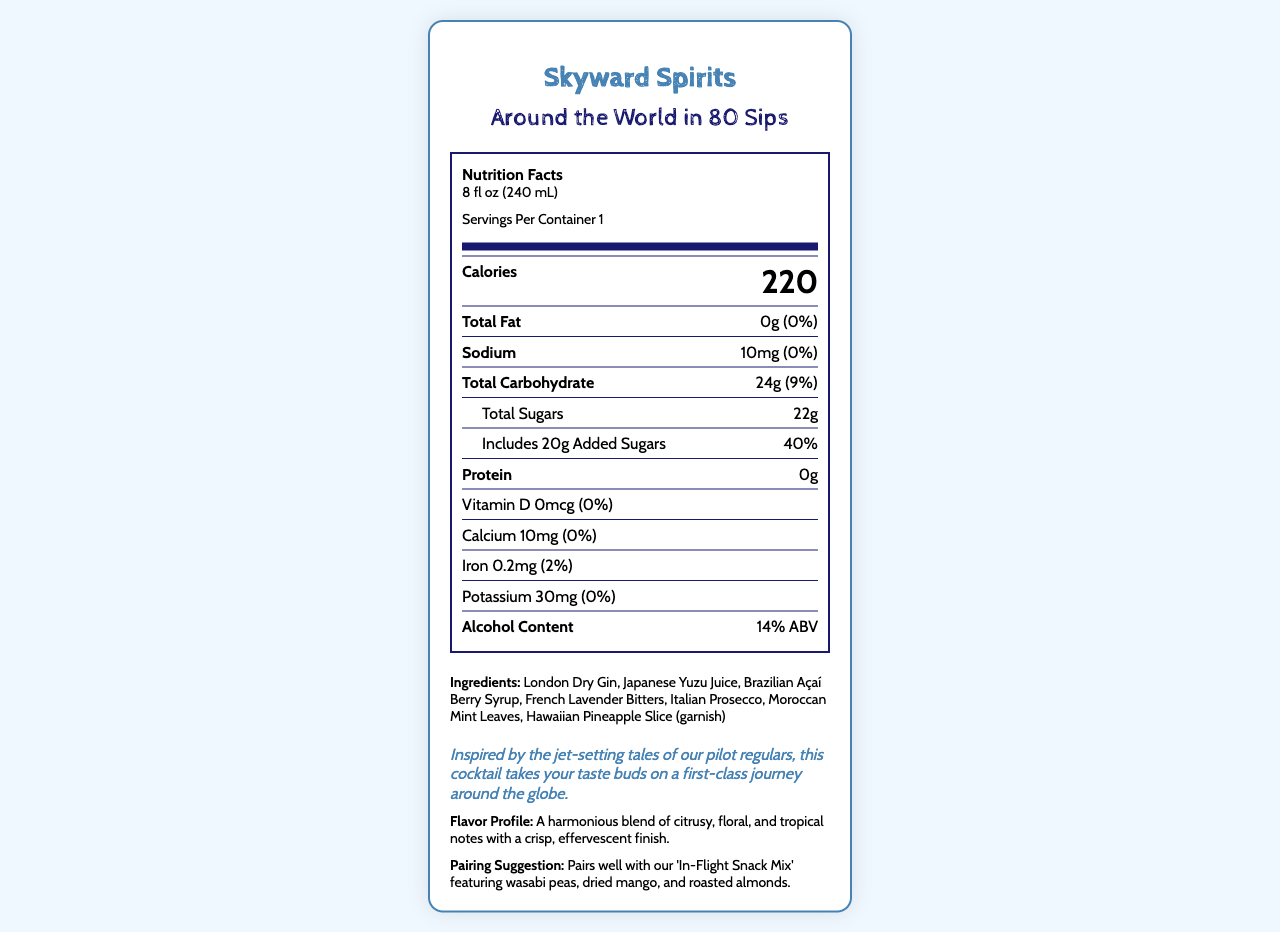what is the product name? The product name is clearly stated at the beginning of the document.
Answer: Around the World in 80 Sips what is the serving size of the cocktail? The serving size is specified in the document as "8 fl oz (240 mL)".
Answer: 8 fl oz (240 mL) how many calories are in one serving? The document lists the calorie content for one serving as 220 calories.
Answer: 220 what is the amount of total fat in this cocktail? The document states that the total fat content is 0g.
Answer: 0g how much added sugar is included in the cocktail? According to the document, the cocktail includes 20g of added sugars.
Answer: 20g what is the alcohol content of the cocktail? The document specifies that the alcohol content is 14% ABV.
Answer: 14% ABV Which of the following ingredients is used as a garnish? A. French Lavender Bitters B. Hawaiian Pineapple Slice C. Italian Prosecco D. Moroccan Mint Leaves The document lists "Hawaiian Pineapple Slice (garnish)" among the ingredients.
Answer: B. Hawaiian Pineapple Slice How many grams of protein does the cocktail contain? The document states that the protein content is 0g.
Answer: 0g what is the daily value percentage for calcium in the cocktail? The document shows that the daily value percentage for calcium is 0%.
Answer: 0% Which of the following best describes the flavor profile of the cocktail? I. Sour II. Bitter III. Citrusy IV. Spicy The document mentions "A harmonious blend of citrusy, floral, and tropical notes with a crisp, effervescent finish." under the flavor profile section.
Answer: III. Citrusy Does this cocktail contain any common allergens? The document states that the cocktail contains no common allergens.
Answer: No Describe the main idea of the document. The document details various aspects of the cocktail, such as its nutritional content, ingredients, and other relevant characteristics aimed at informing and appealing to potential consumers.
Answer: The document provides a detailed nutrition facts label for the specialty aviation-themed cocktail "Around the World in 80 Sips," including its serving size, calorie content, nutritional information, ingredients, alcohol content, flavor profile, and pairing suggestion. from which countries are the ingredients inspired? The ingredients listed in the document are inspired by different flight destinations: London (Dry Gin), Japan (Yuzu Juice), Brazil (Açaí Berry Syrup), France (Lavender Bitters), Italy (Prosecco), Morocco (Mint Leaves), and Hawaii (Pineapple Slice).
Answer: London, Japan, Brazil, France, Italy, Morocco, and Hawaii what is the bartender note included in the document? The bartender's note in the document states, "Inspired by the jet-setting tales of our pilot regulars, this cocktail takes your taste buds on a first-class journey around the globe."
Answer: "Inspired by the jet-setting tales of our pilot regulars, this cocktail takes your taste buds on a first-class journey around the globe." What pairing suggestion is provided for the cocktail? The document suggests that the cocktail pairs well with the 'In-Flight Snack Mix' that includes wasabi peas, dried mango, and roasted almonds.
Answer: "Pairs well with our 'In-Flight Snack Mix' featuring wasabi peas, dried mango, and roasted almonds." Are there any vitamin D in this cocktail? The document indicates that the vitamin D content is 0mcg.
Answer: No how much potassium does the cocktail contain? The document states that the potassium content is 30mg.
Answer: 30mg What type of font is used in the body of the document? The type of font used in the body of the document is not provided in the visual information of the nutrition label.
Answer: Cannot be determined 